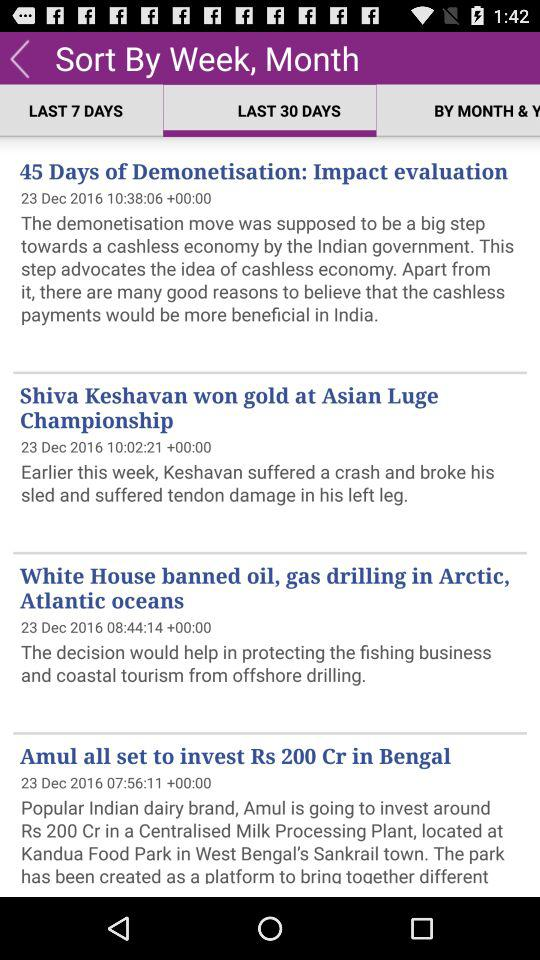What are the headlines? The headlines are "45 Days of Demonetisation: Impact evaluation", "Shiva Keshavan won gold at Asian Luge Championship", "White House banned oil, gas drilling in Arctic, Atlantic oceans" and "Amul all set to invest Rs 200 Cr in Bengal". 